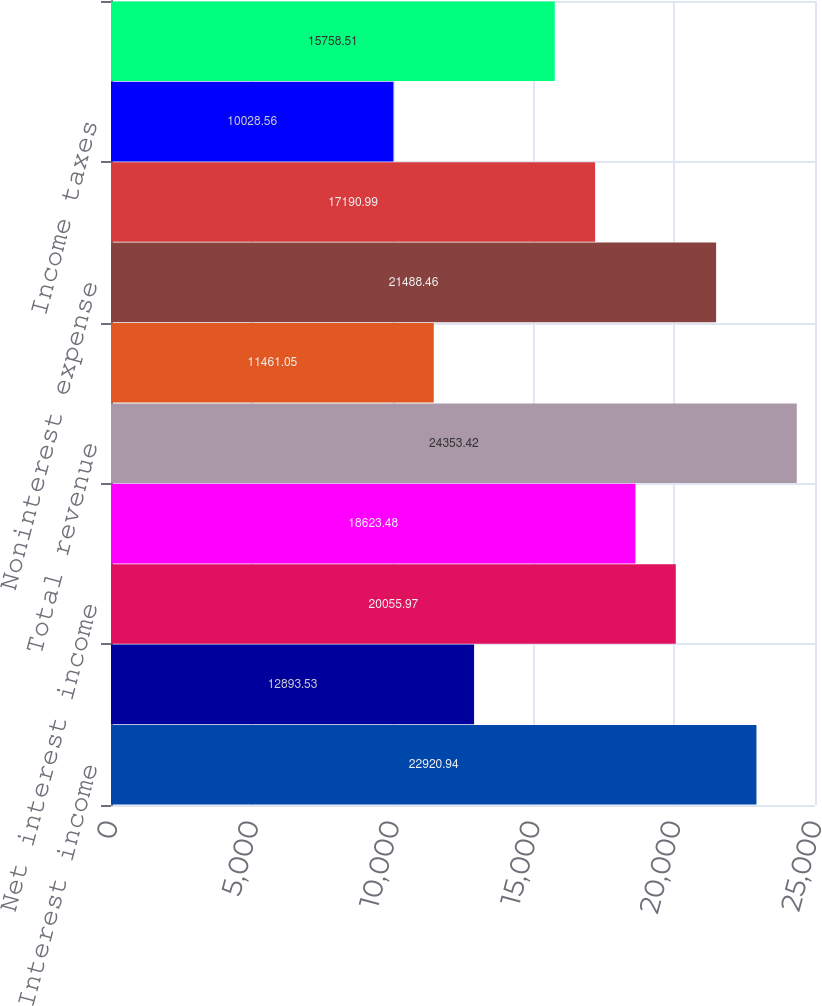Convert chart. <chart><loc_0><loc_0><loc_500><loc_500><bar_chart><fcel>Interest income<fcel>Interest expense<fcel>Net interest income<fcel>Noninterest income<fcel>Total revenue<fcel>Provision for credit losses<fcel>Noninterest expense<fcel>Income before income taxes and<fcel>Income taxes<fcel>Net income<nl><fcel>22920.9<fcel>12893.5<fcel>20056<fcel>18623.5<fcel>24353.4<fcel>11461<fcel>21488.5<fcel>17191<fcel>10028.6<fcel>15758.5<nl></chart> 